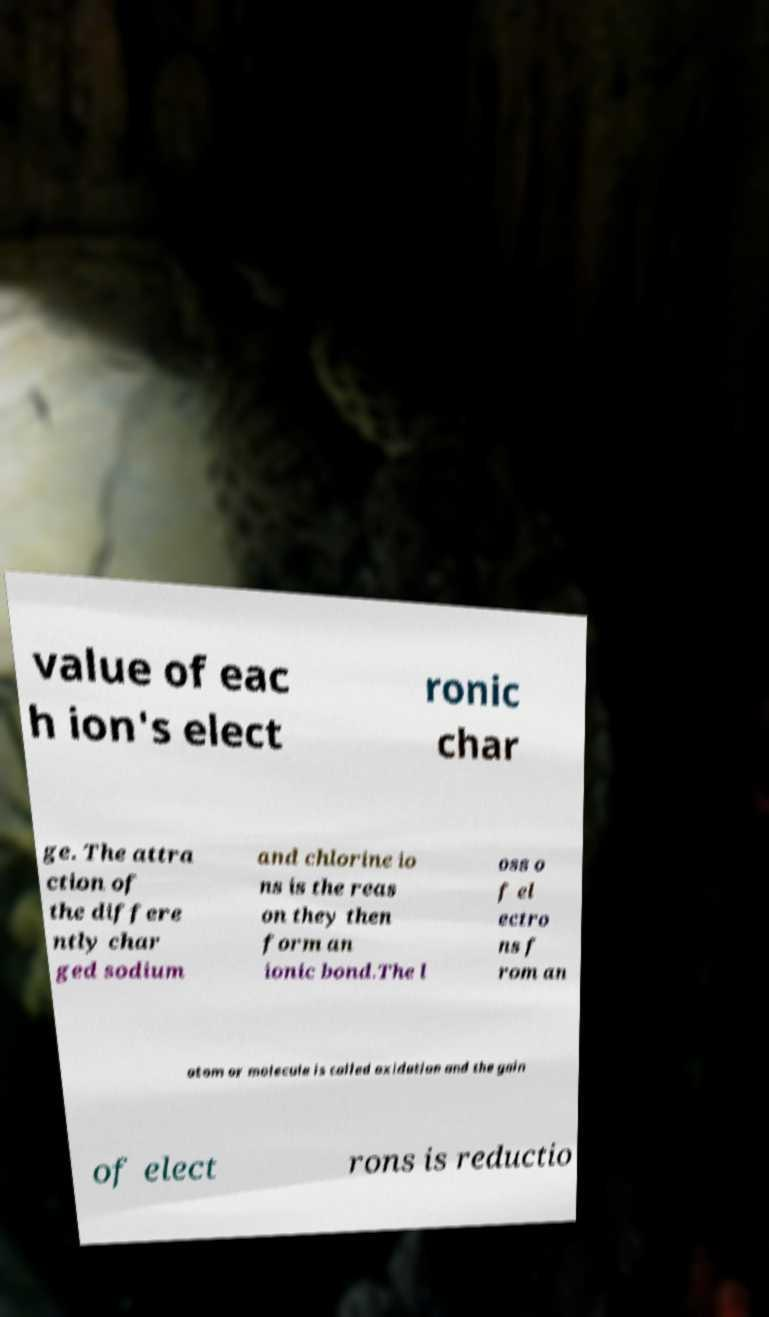Please identify and transcribe the text found in this image. value of eac h ion's elect ronic char ge. The attra ction of the differe ntly char ged sodium and chlorine io ns is the reas on they then form an ionic bond.The l oss o f el ectro ns f rom an atom or molecule is called oxidation and the gain of elect rons is reductio 